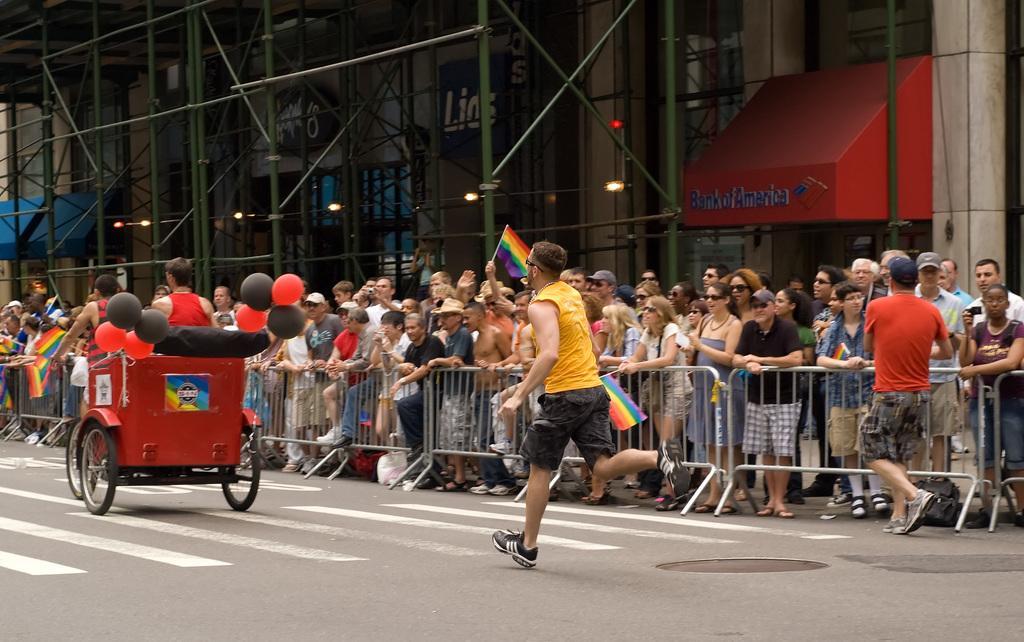Describe this image in one or two sentences. In this image, we can some people standing, there is a man running on the road, we can see a cycle rickshaw, there is a building. 